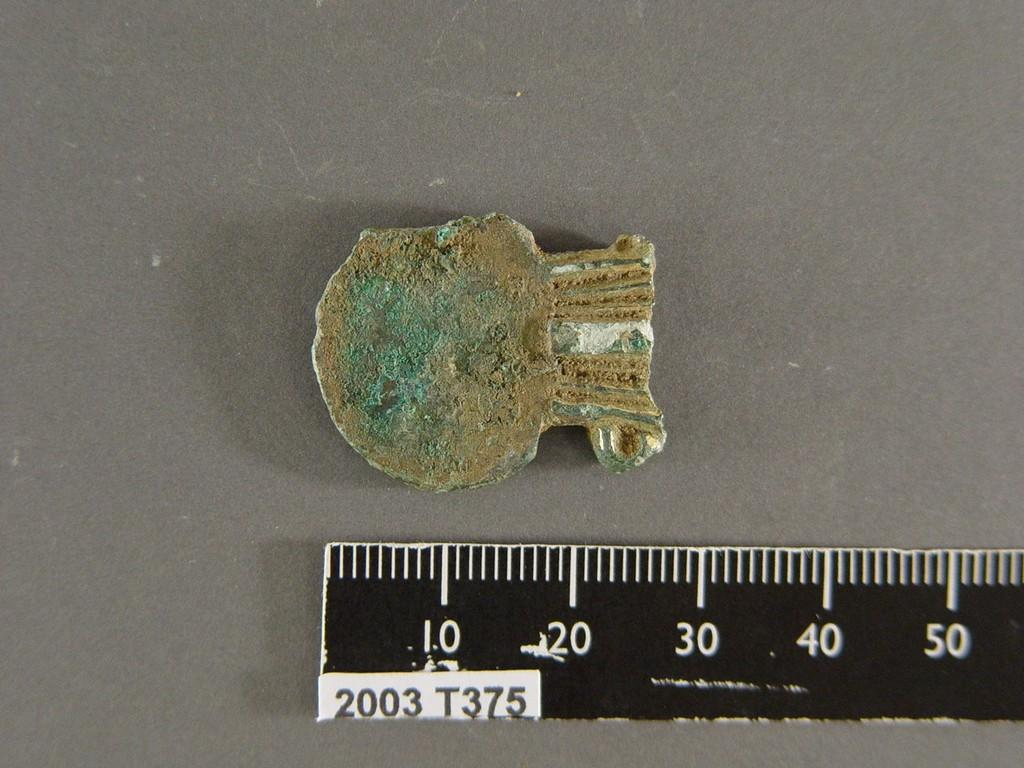<image>
Describe the image concisely. piece of broken stone or pottery object next to ruler with 2003 T375 on it 